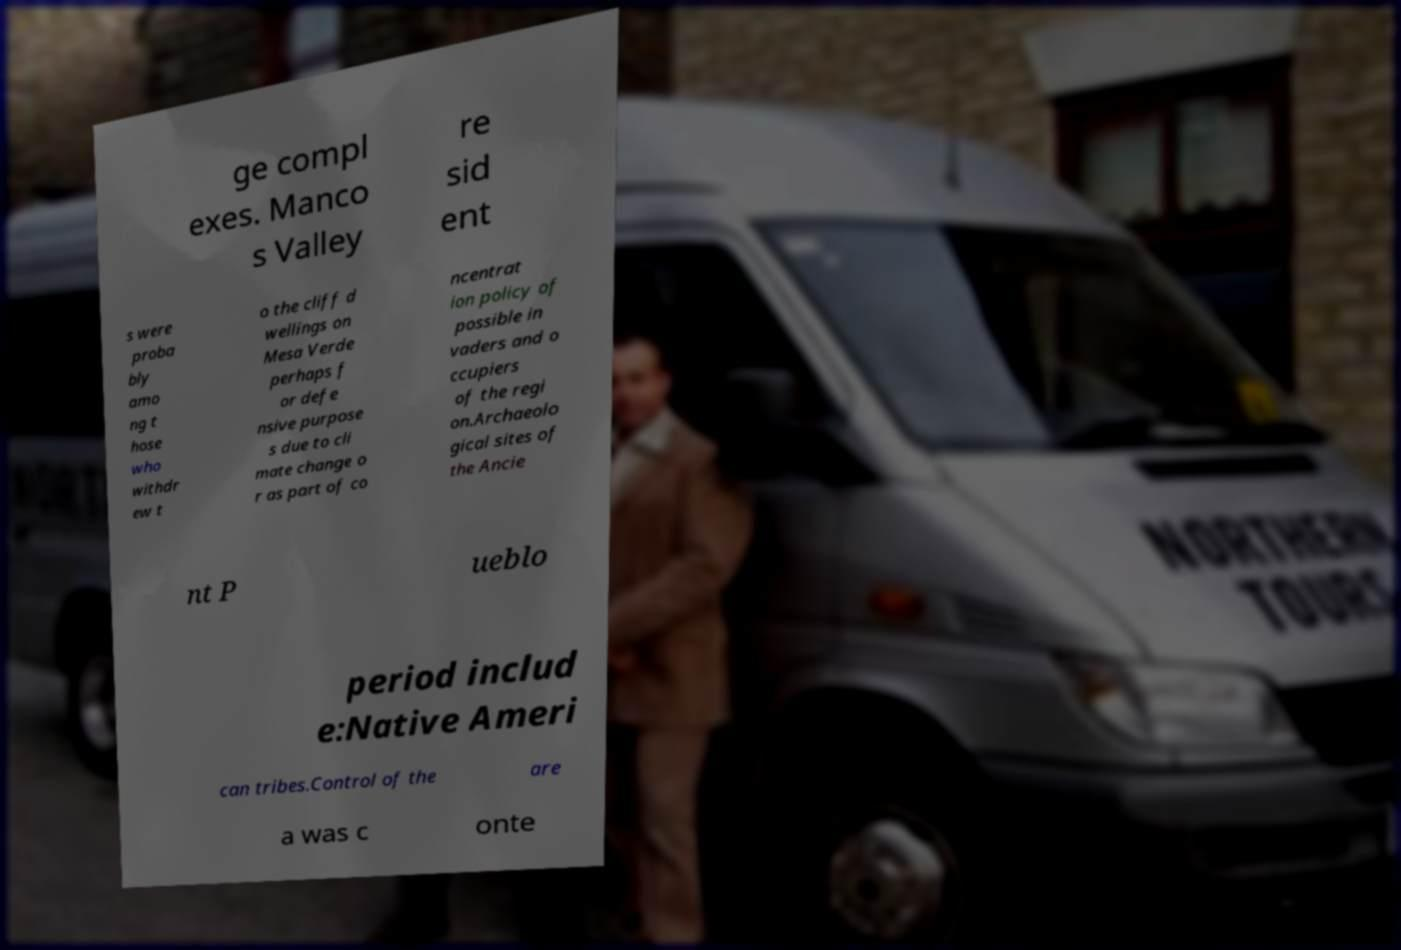Can you read and provide the text displayed in the image?This photo seems to have some interesting text. Can you extract and type it out for me? ge compl exes. Manco s Valley re sid ent s were proba bly amo ng t hose who withdr ew t o the cliff d wellings on Mesa Verde perhaps f or defe nsive purpose s due to cli mate change o r as part of co ncentrat ion policy of possible in vaders and o ccupiers of the regi on.Archaeolo gical sites of the Ancie nt P ueblo period includ e:Native Ameri can tribes.Control of the are a was c onte 